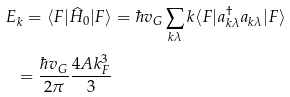Convert formula to latex. <formula><loc_0><loc_0><loc_500><loc_500>E _ { k } = \langle F | \widehat { H } _ { 0 } | F \rangle & = \hbar { v } _ { G } \sum _ { { k } \lambda } k \langle F | a ^ { \dagger } _ { { k } \lambda } a _ { { k } \lambda } | F \rangle \\ = \frac { \hbar { v } _ { G } } { 2 \pi } \frac { 4 A k _ { F } ^ { 3 } } { 3 }</formula> 